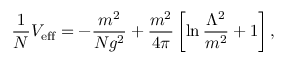<formula> <loc_0><loc_0><loc_500><loc_500>\frac { 1 } { N } V _ { e f f } = - \frac { m ^ { 2 } } { N g ^ { 2 } } + \frac { m ^ { 2 } } { 4 \pi } \left [ \ln \frac { \Lambda ^ { 2 } } { m ^ { 2 } } + 1 \right ] ,</formula> 